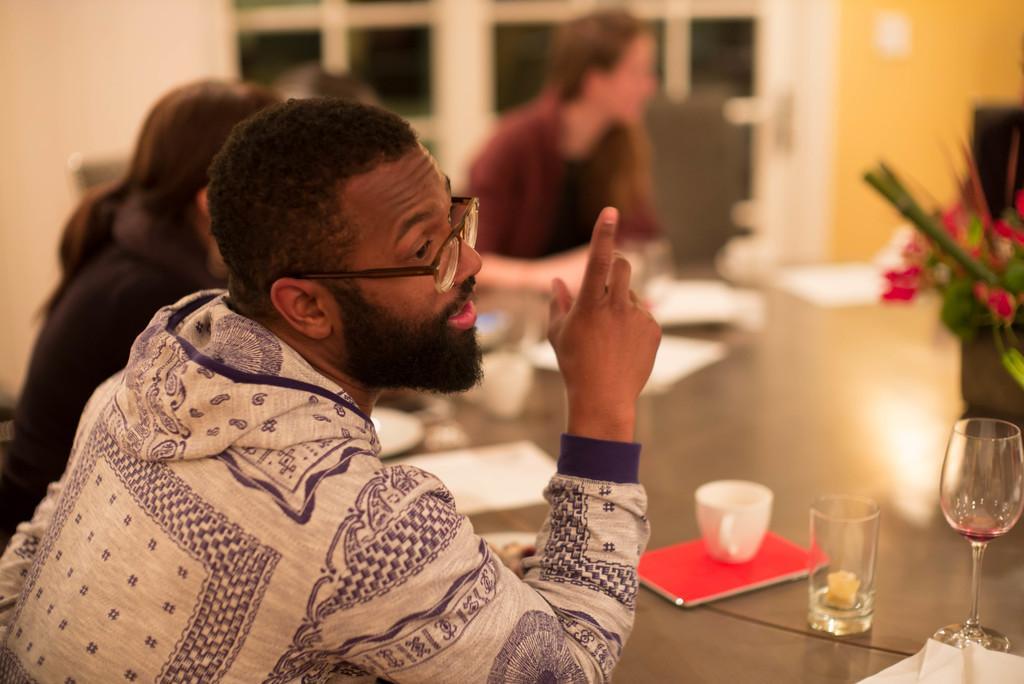How would you summarize this image in a sentence or two? In the image we can see few persons were sitting on the chair around the table. On table we can see wine glass,cup,book,paper and flower vase. In the background there is a wall and window. 